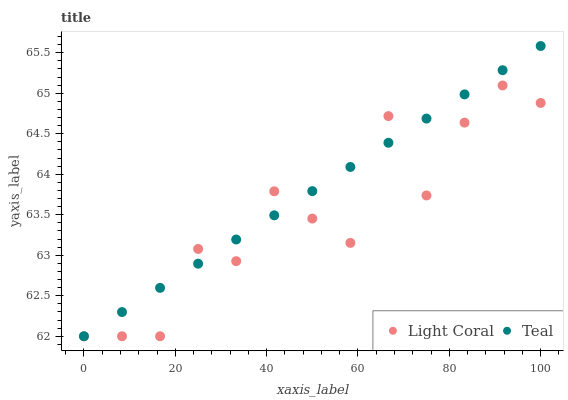Does Light Coral have the minimum area under the curve?
Answer yes or no. Yes. Does Teal have the maximum area under the curve?
Answer yes or no. Yes. Does Teal have the minimum area under the curve?
Answer yes or no. No. Is Teal the smoothest?
Answer yes or no. Yes. Is Light Coral the roughest?
Answer yes or no. Yes. Is Teal the roughest?
Answer yes or no. No. Does Light Coral have the lowest value?
Answer yes or no. Yes. Does Teal have the highest value?
Answer yes or no. Yes. Does Teal intersect Light Coral?
Answer yes or no. Yes. Is Teal less than Light Coral?
Answer yes or no. No. Is Teal greater than Light Coral?
Answer yes or no. No. 